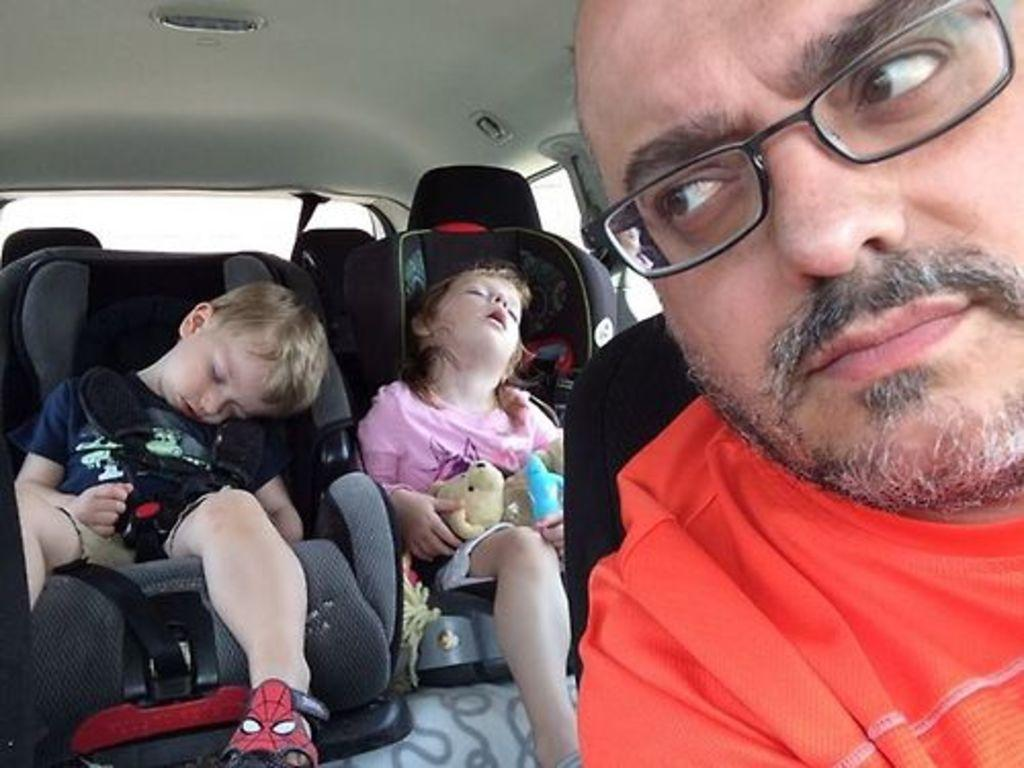How many people are present in the image? There are three people in the image: a boy, a girl, and a man. What are the people in the image doing? The boy and girl are sleeping, and the man is likely driving, as they are sitting on seats inside a car. What type of vehicle is shown in the image? The image shows the inside view of a car. What type of pencil can be seen in the image? There is no pencil present in the image. Can you hear the thunder in the image? There is no sound or indication of thunder in the image. 